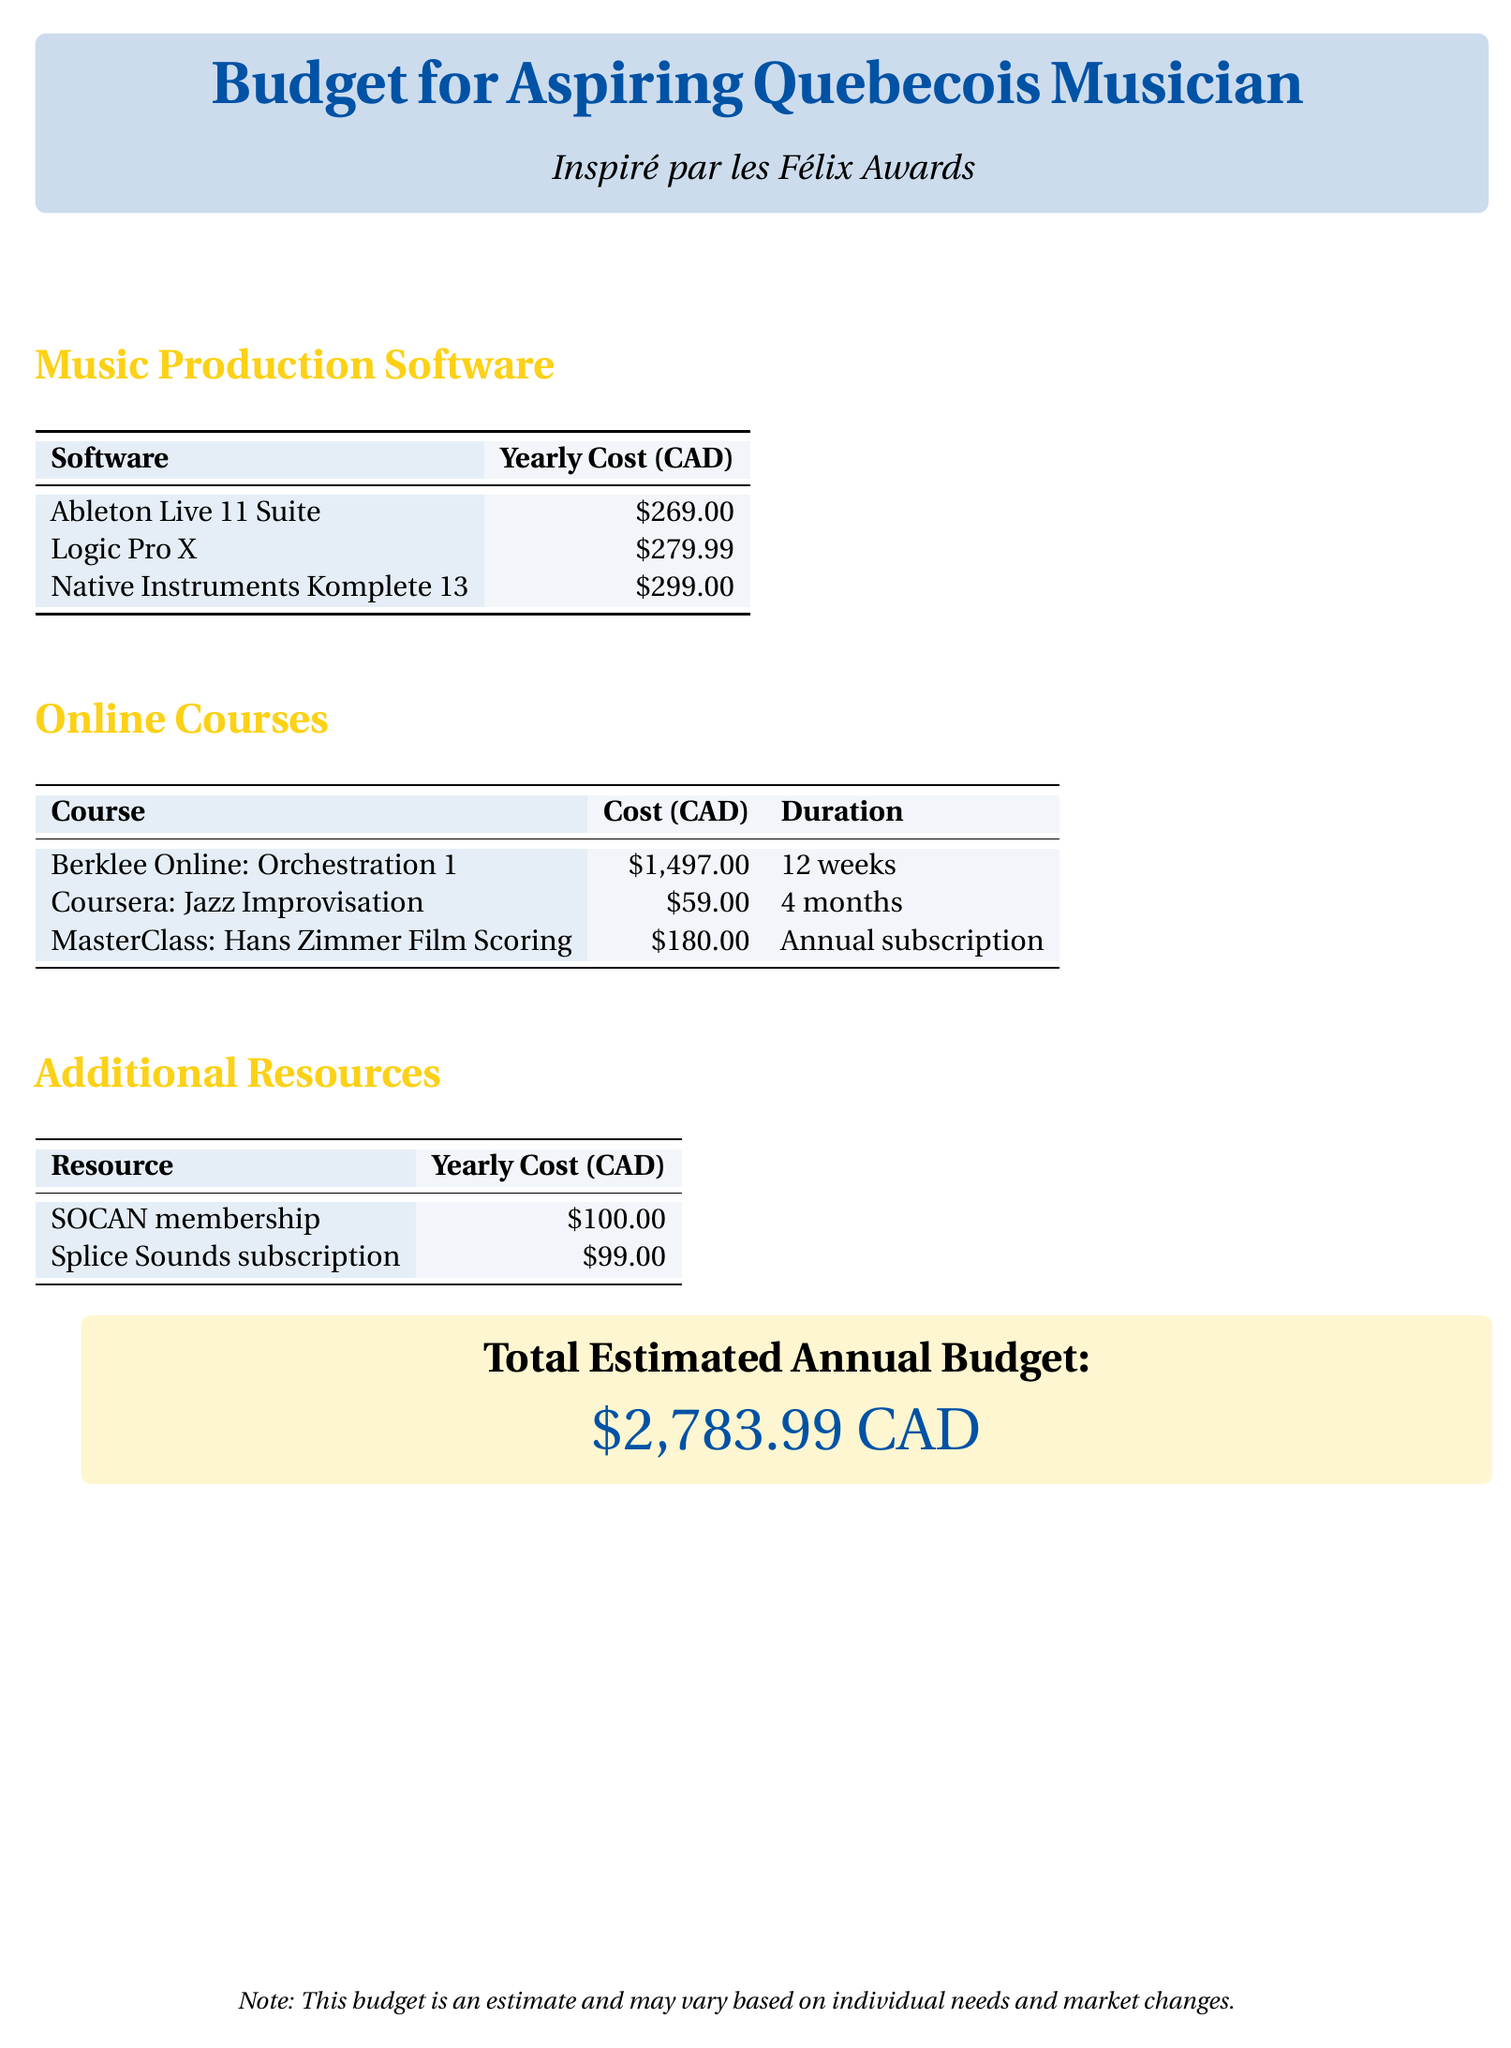What is the yearly cost of Ableton Live 11 Suite? The document specifies a cost of $269.00 for Ableton Live 11 Suite.
Answer: $269.00 What is the duration of the Berklee Online: Orchestration 1 course? The document lists the duration of the Berklee Online: Orchestration 1 course as 12 weeks.
Answer: 12 weeks What is the total estimated annual budget? The document states the total estimated annual budget is $2,783.99 CAD, which includes all expenses listed.
Answer: $2,783.99 CAD How much does a SOCAN membership cost per year? According to the document, a SOCAN membership costs $100.00 per year.
Answer: $100.00 What online course costs the least? The document indicates that the Coursera: Jazz Improvisation course has the least cost at $59.00.
Answer: $59.00 What is the yearly cost of Splice Sounds subscription? The document indicates that the Splice Sounds subscription costs $99.00 per year.
Answer: $99.00 What is the total cost for all music production software listed? The yearly costs of all music production software ($269.00 + $279.99 + $299.00) sum up to determine the total for that category.
Answer: $847.99 How many online courses are listed in the document? The document lists three online courses available for aspiring musicians.
Answer: 3 What is the cost of the MasterClass: Hans Zimmer Film Scoring course? The document states that the MasterClass: Hans Zimmer Film Scoring course has an annual subscription cost of $180.00.
Answer: $180.00 